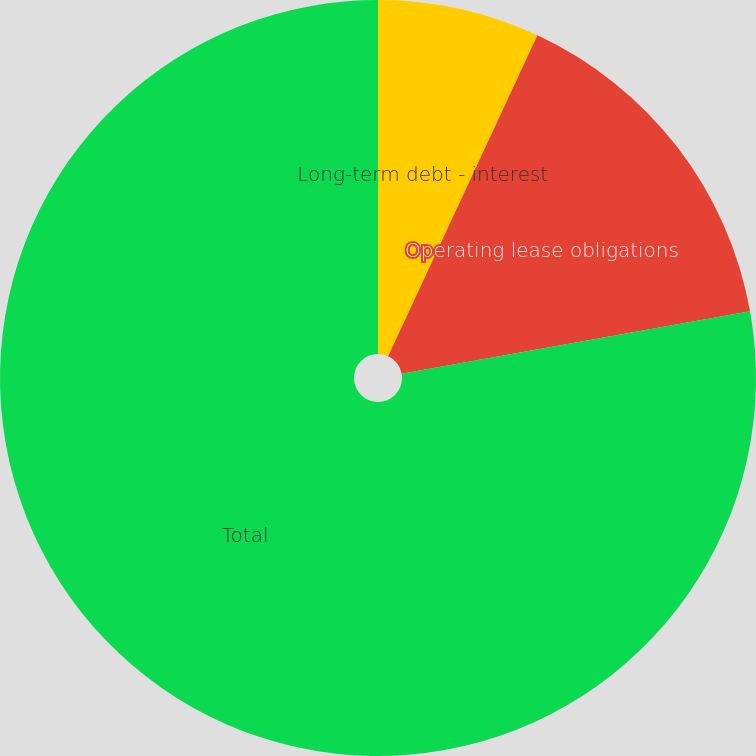Convert chart to OTSL. <chart><loc_0><loc_0><loc_500><loc_500><pie_chart><fcel>Long-term debt - interest<fcel>Operating lease obligations<fcel>Total<nl><fcel>6.93%<fcel>15.25%<fcel>77.82%<nl></chart> 